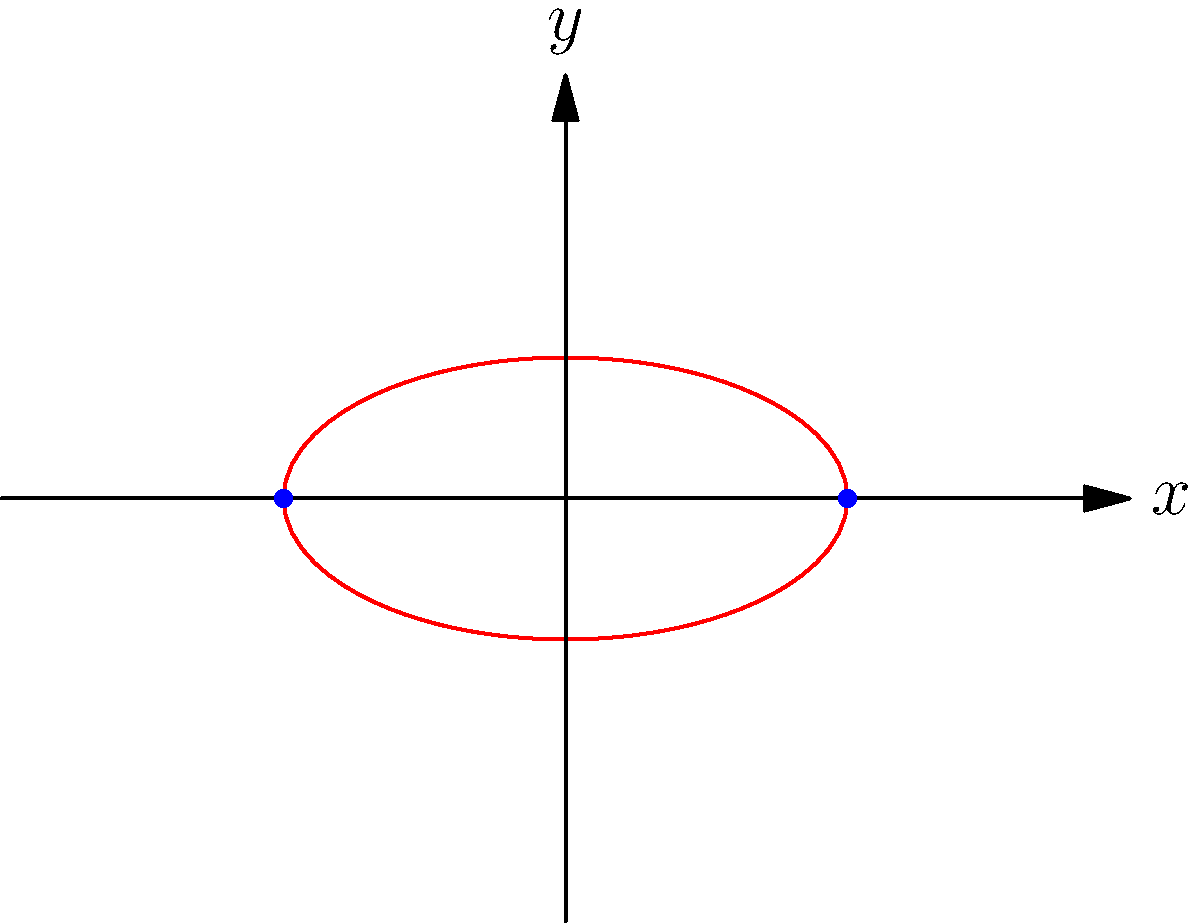As a research scientist specializing in analytic geometry, you're studying the polar form of a hyperbola. The graph above represents a hyperbola in polar coordinates. Given that the equation of this hyperbola is $r = \frac{ab}{\sqrt{b^2\cos^2\theta + a^2\sin^2\theta}}$, where $a > b > 0$, what is the eccentricity of this hyperbola? To find the eccentricity of the hyperbola, we'll follow these steps:

1) The eccentricity (e) of a hyperbola is defined as $e = \sqrt{1 + \frac{b^2}{a^2}}$, where $a$ is the distance from the center to a vertex, and $b$ is the length of the conjugate semi-axis.

2) From the given polar equation, we can identify that:
   - $a$ is the distance from the center to a vertex (on the x-axis)
   - $b$ is the length of the conjugate semi-axis (on the y-axis)

3) We're told that $a > b > 0$, which is consistent with the standard form of a hyperbola with its transverse axis along the x-axis.

4) Substituting these into the eccentricity formula:

   $e = \sqrt{1 + \frac{b^2}{a^2}}$

5) We can simplify this further:

   $e = \sqrt{\frac{a^2 + b^2}{a^2}}$

6) This can be rewritten as:

   $e = \frac{\sqrt{a^2 + b^2}}{a}$

This is the eccentricity of the hyperbola in terms of $a$ and $b$.
Answer: $e = \frac{\sqrt{a^2 + b^2}}{a}$ 